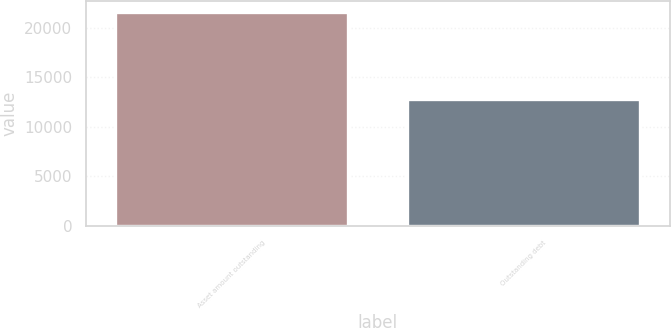<chart> <loc_0><loc_0><loc_500><loc_500><bar_chart><fcel>Asset amount outstanding<fcel>Outstanding debt<nl><fcel>21636<fcel>12824<nl></chart> 